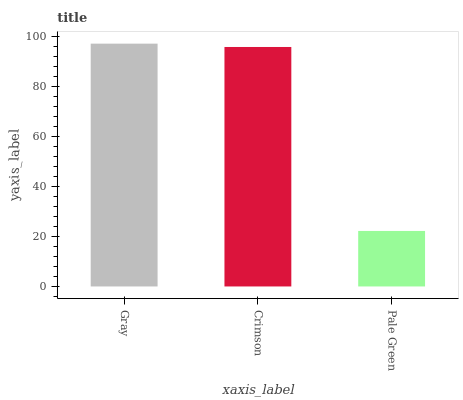Is Crimson the minimum?
Answer yes or no. No. Is Crimson the maximum?
Answer yes or no. No. Is Gray greater than Crimson?
Answer yes or no. Yes. Is Crimson less than Gray?
Answer yes or no. Yes. Is Crimson greater than Gray?
Answer yes or no. No. Is Gray less than Crimson?
Answer yes or no. No. Is Crimson the high median?
Answer yes or no. Yes. Is Crimson the low median?
Answer yes or no. Yes. Is Gray the high median?
Answer yes or no. No. Is Pale Green the low median?
Answer yes or no. No. 